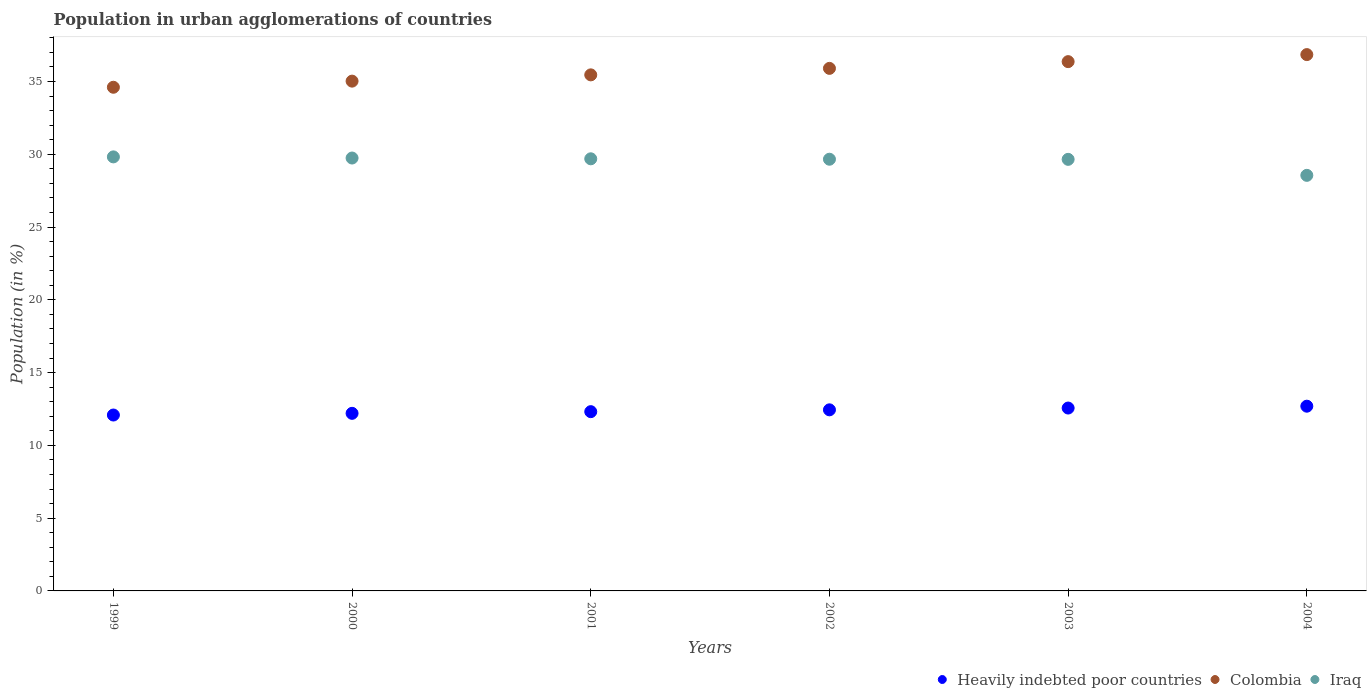What is the percentage of population in urban agglomerations in Heavily indebted poor countries in 2001?
Provide a succinct answer. 12.32. Across all years, what is the maximum percentage of population in urban agglomerations in Colombia?
Your answer should be compact. 36.85. Across all years, what is the minimum percentage of population in urban agglomerations in Colombia?
Your response must be concise. 34.61. In which year was the percentage of population in urban agglomerations in Colombia minimum?
Make the answer very short. 1999. What is the total percentage of population in urban agglomerations in Heavily indebted poor countries in the graph?
Offer a very short reply. 74.31. What is the difference between the percentage of population in urban agglomerations in Iraq in 1999 and that in 2001?
Your response must be concise. 0.13. What is the difference between the percentage of population in urban agglomerations in Iraq in 1999 and the percentage of population in urban agglomerations in Colombia in 2001?
Keep it short and to the point. -5.64. What is the average percentage of population in urban agglomerations in Heavily indebted poor countries per year?
Give a very brief answer. 12.38. In the year 2001, what is the difference between the percentage of population in urban agglomerations in Iraq and percentage of population in urban agglomerations in Colombia?
Provide a succinct answer. -5.77. In how many years, is the percentage of population in urban agglomerations in Colombia greater than 30 %?
Keep it short and to the point. 6. What is the ratio of the percentage of population in urban agglomerations in Heavily indebted poor countries in 2000 to that in 2001?
Your answer should be compact. 0.99. What is the difference between the highest and the second highest percentage of population in urban agglomerations in Iraq?
Give a very brief answer. 0.08. What is the difference between the highest and the lowest percentage of population in urban agglomerations in Iraq?
Provide a succinct answer. 1.27. In how many years, is the percentage of population in urban agglomerations in Iraq greater than the average percentage of population in urban agglomerations in Iraq taken over all years?
Make the answer very short. 5. Is it the case that in every year, the sum of the percentage of population in urban agglomerations in Heavily indebted poor countries and percentage of population in urban agglomerations in Colombia  is greater than the percentage of population in urban agglomerations in Iraq?
Your answer should be compact. Yes. Is the percentage of population in urban agglomerations in Iraq strictly greater than the percentage of population in urban agglomerations in Colombia over the years?
Offer a very short reply. No. Is the percentage of population in urban agglomerations in Colombia strictly less than the percentage of population in urban agglomerations in Iraq over the years?
Keep it short and to the point. No. Are the values on the major ticks of Y-axis written in scientific E-notation?
Ensure brevity in your answer.  No. Does the graph contain any zero values?
Your answer should be compact. No. Does the graph contain grids?
Your answer should be very brief. No. How many legend labels are there?
Your response must be concise. 3. How are the legend labels stacked?
Your answer should be compact. Horizontal. What is the title of the graph?
Your answer should be very brief. Population in urban agglomerations of countries. Does "Tonga" appear as one of the legend labels in the graph?
Your answer should be very brief. No. What is the label or title of the Y-axis?
Provide a short and direct response. Population (in %). What is the Population (in %) in Heavily indebted poor countries in 1999?
Keep it short and to the point. 12.09. What is the Population (in %) in Colombia in 1999?
Make the answer very short. 34.61. What is the Population (in %) in Iraq in 1999?
Your response must be concise. 29.82. What is the Population (in %) of Heavily indebted poor countries in 2000?
Your answer should be compact. 12.2. What is the Population (in %) of Colombia in 2000?
Your response must be concise. 35.03. What is the Population (in %) in Iraq in 2000?
Your answer should be very brief. 29.74. What is the Population (in %) in Heavily indebted poor countries in 2001?
Your response must be concise. 12.32. What is the Population (in %) in Colombia in 2001?
Your answer should be very brief. 35.46. What is the Population (in %) of Iraq in 2001?
Offer a very short reply. 29.69. What is the Population (in %) in Heavily indebted poor countries in 2002?
Your response must be concise. 12.44. What is the Population (in %) of Colombia in 2002?
Offer a terse response. 35.91. What is the Population (in %) of Iraq in 2002?
Ensure brevity in your answer.  29.66. What is the Population (in %) of Heavily indebted poor countries in 2003?
Keep it short and to the point. 12.57. What is the Population (in %) of Colombia in 2003?
Offer a very short reply. 36.37. What is the Population (in %) of Iraq in 2003?
Offer a very short reply. 29.65. What is the Population (in %) of Heavily indebted poor countries in 2004?
Ensure brevity in your answer.  12.69. What is the Population (in %) of Colombia in 2004?
Give a very brief answer. 36.85. What is the Population (in %) in Iraq in 2004?
Ensure brevity in your answer.  28.55. Across all years, what is the maximum Population (in %) in Heavily indebted poor countries?
Provide a short and direct response. 12.69. Across all years, what is the maximum Population (in %) of Colombia?
Keep it short and to the point. 36.85. Across all years, what is the maximum Population (in %) of Iraq?
Offer a very short reply. 29.82. Across all years, what is the minimum Population (in %) of Heavily indebted poor countries?
Offer a very short reply. 12.09. Across all years, what is the minimum Population (in %) in Colombia?
Ensure brevity in your answer.  34.61. Across all years, what is the minimum Population (in %) in Iraq?
Provide a short and direct response. 28.55. What is the total Population (in %) of Heavily indebted poor countries in the graph?
Your response must be concise. 74.31. What is the total Population (in %) in Colombia in the graph?
Offer a terse response. 214.22. What is the total Population (in %) in Iraq in the graph?
Offer a terse response. 177.13. What is the difference between the Population (in %) of Heavily indebted poor countries in 1999 and that in 2000?
Give a very brief answer. -0.12. What is the difference between the Population (in %) of Colombia in 1999 and that in 2000?
Offer a very short reply. -0.42. What is the difference between the Population (in %) of Iraq in 1999 and that in 2000?
Your response must be concise. 0.08. What is the difference between the Population (in %) of Heavily indebted poor countries in 1999 and that in 2001?
Your response must be concise. -0.23. What is the difference between the Population (in %) of Colombia in 1999 and that in 2001?
Make the answer very short. -0.85. What is the difference between the Population (in %) in Iraq in 1999 and that in 2001?
Keep it short and to the point. 0.13. What is the difference between the Population (in %) in Heavily indebted poor countries in 1999 and that in 2002?
Provide a short and direct response. -0.36. What is the difference between the Population (in %) in Colombia in 1999 and that in 2002?
Keep it short and to the point. -1.3. What is the difference between the Population (in %) of Iraq in 1999 and that in 2002?
Your answer should be very brief. 0.16. What is the difference between the Population (in %) of Heavily indebted poor countries in 1999 and that in 2003?
Your response must be concise. -0.48. What is the difference between the Population (in %) in Colombia in 1999 and that in 2003?
Your response must be concise. -1.76. What is the difference between the Population (in %) of Iraq in 1999 and that in 2003?
Give a very brief answer. 0.17. What is the difference between the Population (in %) of Heavily indebted poor countries in 1999 and that in 2004?
Provide a succinct answer. -0.61. What is the difference between the Population (in %) of Colombia in 1999 and that in 2004?
Offer a very short reply. -2.24. What is the difference between the Population (in %) in Iraq in 1999 and that in 2004?
Keep it short and to the point. 1.27. What is the difference between the Population (in %) of Heavily indebted poor countries in 2000 and that in 2001?
Make the answer very short. -0.12. What is the difference between the Population (in %) of Colombia in 2000 and that in 2001?
Provide a short and direct response. -0.43. What is the difference between the Population (in %) in Iraq in 2000 and that in 2001?
Provide a succinct answer. 0.05. What is the difference between the Population (in %) in Heavily indebted poor countries in 2000 and that in 2002?
Offer a terse response. -0.24. What is the difference between the Population (in %) in Colombia in 2000 and that in 2002?
Your answer should be compact. -0.88. What is the difference between the Population (in %) of Iraq in 2000 and that in 2002?
Your answer should be very brief. 0.08. What is the difference between the Population (in %) of Heavily indebted poor countries in 2000 and that in 2003?
Provide a succinct answer. -0.36. What is the difference between the Population (in %) in Colombia in 2000 and that in 2003?
Keep it short and to the point. -1.34. What is the difference between the Population (in %) in Iraq in 2000 and that in 2003?
Provide a succinct answer. 0.09. What is the difference between the Population (in %) of Heavily indebted poor countries in 2000 and that in 2004?
Give a very brief answer. -0.49. What is the difference between the Population (in %) in Colombia in 2000 and that in 2004?
Your answer should be compact. -1.82. What is the difference between the Population (in %) of Iraq in 2000 and that in 2004?
Your answer should be compact. 1.19. What is the difference between the Population (in %) in Heavily indebted poor countries in 2001 and that in 2002?
Your answer should be very brief. -0.13. What is the difference between the Population (in %) in Colombia in 2001 and that in 2002?
Make the answer very short. -0.45. What is the difference between the Population (in %) of Iraq in 2001 and that in 2002?
Ensure brevity in your answer.  0.03. What is the difference between the Population (in %) in Heavily indebted poor countries in 2001 and that in 2003?
Ensure brevity in your answer.  -0.25. What is the difference between the Population (in %) of Colombia in 2001 and that in 2003?
Make the answer very short. -0.91. What is the difference between the Population (in %) in Iraq in 2001 and that in 2003?
Your answer should be compact. 0.04. What is the difference between the Population (in %) of Heavily indebted poor countries in 2001 and that in 2004?
Keep it short and to the point. -0.38. What is the difference between the Population (in %) of Colombia in 2001 and that in 2004?
Offer a terse response. -1.39. What is the difference between the Population (in %) in Iraq in 2001 and that in 2004?
Keep it short and to the point. 1.14. What is the difference between the Population (in %) in Heavily indebted poor countries in 2002 and that in 2003?
Keep it short and to the point. -0.12. What is the difference between the Population (in %) of Colombia in 2002 and that in 2003?
Your answer should be compact. -0.46. What is the difference between the Population (in %) of Iraq in 2002 and that in 2003?
Keep it short and to the point. 0.01. What is the difference between the Population (in %) of Heavily indebted poor countries in 2002 and that in 2004?
Give a very brief answer. -0.25. What is the difference between the Population (in %) in Colombia in 2002 and that in 2004?
Offer a terse response. -0.95. What is the difference between the Population (in %) in Iraq in 2002 and that in 2004?
Your answer should be very brief. 1.11. What is the difference between the Population (in %) of Heavily indebted poor countries in 2003 and that in 2004?
Provide a succinct answer. -0.13. What is the difference between the Population (in %) in Colombia in 2003 and that in 2004?
Give a very brief answer. -0.48. What is the difference between the Population (in %) in Iraq in 2003 and that in 2004?
Your answer should be compact. 1.1. What is the difference between the Population (in %) in Heavily indebted poor countries in 1999 and the Population (in %) in Colombia in 2000?
Your answer should be very brief. -22.94. What is the difference between the Population (in %) of Heavily indebted poor countries in 1999 and the Population (in %) of Iraq in 2000?
Offer a terse response. -17.66. What is the difference between the Population (in %) of Colombia in 1999 and the Population (in %) of Iraq in 2000?
Provide a short and direct response. 4.86. What is the difference between the Population (in %) of Heavily indebted poor countries in 1999 and the Population (in %) of Colombia in 2001?
Give a very brief answer. -23.37. What is the difference between the Population (in %) of Heavily indebted poor countries in 1999 and the Population (in %) of Iraq in 2001?
Make the answer very short. -17.61. What is the difference between the Population (in %) of Colombia in 1999 and the Population (in %) of Iraq in 2001?
Offer a terse response. 4.92. What is the difference between the Population (in %) in Heavily indebted poor countries in 1999 and the Population (in %) in Colombia in 2002?
Ensure brevity in your answer.  -23.82. What is the difference between the Population (in %) in Heavily indebted poor countries in 1999 and the Population (in %) in Iraq in 2002?
Keep it short and to the point. -17.58. What is the difference between the Population (in %) in Colombia in 1999 and the Population (in %) in Iraq in 2002?
Your answer should be very brief. 4.95. What is the difference between the Population (in %) in Heavily indebted poor countries in 1999 and the Population (in %) in Colombia in 2003?
Your response must be concise. -24.28. What is the difference between the Population (in %) of Heavily indebted poor countries in 1999 and the Population (in %) of Iraq in 2003?
Provide a succinct answer. -17.57. What is the difference between the Population (in %) in Colombia in 1999 and the Population (in %) in Iraq in 2003?
Your answer should be compact. 4.95. What is the difference between the Population (in %) of Heavily indebted poor countries in 1999 and the Population (in %) of Colombia in 2004?
Keep it short and to the point. -24.77. What is the difference between the Population (in %) of Heavily indebted poor countries in 1999 and the Population (in %) of Iraq in 2004?
Your answer should be compact. -16.47. What is the difference between the Population (in %) in Colombia in 1999 and the Population (in %) in Iraq in 2004?
Your answer should be very brief. 6.05. What is the difference between the Population (in %) of Heavily indebted poor countries in 2000 and the Population (in %) of Colombia in 2001?
Provide a short and direct response. -23.26. What is the difference between the Population (in %) of Heavily indebted poor countries in 2000 and the Population (in %) of Iraq in 2001?
Provide a short and direct response. -17.49. What is the difference between the Population (in %) in Colombia in 2000 and the Population (in %) in Iraq in 2001?
Your response must be concise. 5.34. What is the difference between the Population (in %) in Heavily indebted poor countries in 2000 and the Population (in %) in Colombia in 2002?
Provide a succinct answer. -23.7. What is the difference between the Population (in %) of Heavily indebted poor countries in 2000 and the Population (in %) of Iraq in 2002?
Offer a very short reply. -17.46. What is the difference between the Population (in %) of Colombia in 2000 and the Population (in %) of Iraq in 2002?
Your answer should be very brief. 5.37. What is the difference between the Population (in %) in Heavily indebted poor countries in 2000 and the Population (in %) in Colombia in 2003?
Provide a short and direct response. -24.17. What is the difference between the Population (in %) in Heavily indebted poor countries in 2000 and the Population (in %) in Iraq in 2003?
Keep it short and to the point. -17.45. What is the difference between the Population (in %) in Colombia in 2000 and the Population (in %) in Iraq in 2003?
Your answer should be very brief. 5.37. What is the difference between the Population (in %) in Heavily indebted poor countries in 2000 and the Population (in %) in Colombia in 2004?
Provide a short and direct response. -24.65. What is the difference between the Population (in %) of Heavily indebted poor countries in 2000 and the Population (in %) of Iraq in 2004?
Make the answer very short. -16.35. What is the difference between the Population (in %) in Colombia in 2000 and the Population (in %) in Iraq in 2004?
Your answer should be compact. 6.47. What is the difference between the Population (in %) of Heavily indebted poor countries in 2001 and the Population (in %) of Colombia in 2002?
Give a very brief answer. -23.59. What is the difference between the Population (in %) in Heavily indebted poor countries in 2001 and the Population (in %) in Iraq in 2002?
Provide a short and direct response. -17.35. What is the difference between the Population (in %) in Colombia in 2001 and the Population (in %) in Iraq in 2002?
Offer a very short reply. 5.8. What is the difference between the Population (in %) in Heavily indebted poor countries in 2001 and the Population (in %) in Colombia in 2003?
Provide a short and direct response. -24.05. What is the difference between the Population (in %) in Heavily indebted poor countries in 2001 and the Population (in %) in Iraq in 2003?
Your response must be concise. -17.34. What is the difference between the Population (in %) in Colombia in 2001 and the Population (in %) in Iraq in 2003?
Provide a succinct answer. 5.81. What is the difference between the Population (in %) in Heavily indebted poor countries in 2001 and the Population (in %) in Colombia in 2004?
Provide a succinct answer. -24.53. What is the difference between the Population (in %) of Heavily indebted poor countries in 2001 and the Population (in %) of Iraq in 2004?
Make the answer very short. -16.24. What is the difference between the Population (in %) of Colombia in 2001 and the Population (in %) of Iraq in 2004?
Keep it short and to the point. 6.9. What is the difference between the Population (in %) in Heavily indebted poor countries in 2002 and the Population (in %) in Colombia in 2003?
Offer a terse response. -23.93. What is the difference between the Population (in %) of Heavily indebted poor countries in 2002 and the Population (in %) of Iraq in 2003?
Ensure brevity in your answer.  -17.21. What is the difference between the Population (in %) in Colombia in 2002 and the Population (in %) in Iraq in 2003?
Offer a very short reply. 6.25. What is the difference between the Population (in %) in Heavily indebted poor countries in 2002 and the Population (in %) in Colombia in 2004?
Give a very brief answer. -24.41. What is the difference between the Population (in %) in Heavily indebted poor countries in 2002 and the Population (in %) in Iraq in 2004?
Your answer should be very brief. -16.11. What is the difference between the Population (in %) in Colombia in 2002 and the Population (in %) in Iraq in 2004?
Keep it short and to the point. 7.35. What is the difference between the Population (in %) in Heavily indebted poor countries in 2003 and the Population (in %) in Colombia in 2004?
Your answer should be compact. -24.29. What is the difference between the Population (in %) of Heavily indebted poor countries in 2003 and the Population (in %) of Iraq in 2004?
Your response must be concise. -15.99. What is the difference between the Population (in %) of Colombia in 2003 and the Population (in %) of Iraq in 2004?
Your response must be concise. 7.81. What is the average Population (in %) of Heavily indebted poor countries per year?
Make the answer very short. 12.38. What is the average Population (in %) in Colombia per year?
Give a very brief answer. 35.7. What is the average Population (in %) in Iraq per year?
Offer a very short reply. 29.52. In the year 1999, what is the difference between the Population (in %) in Heavily indebted poor countries and Population (in %) in Colombia?
Your answer should be very brief. -22.52. In the year 1999, what is the difference between the Population (in %) in Heavily indebted poor countries and Population (in %) in Iraq?
Provide a short and direct response. -17.74. In the year 1999, what is the difference between the Population (in %) in Colombia and Population (in %) in Iraq?
Make the answer very short. 4.78. In the year 2000, what is the difference between the Population (in %) in Heavily indebted poor countries and Population (in %) in Colombia?
Make the answer very short. -22.83. In the year 2000, what is the difference between the Population (in %) of Heavily indebted poor countries and Population (in %) of Iraq?
Make the answer very short. -17.54. In the year 2000, what is the difference between the Population (in %) in Colombia and Population (in %) in Iraq?
Make the answer very short. 5.28. In the year 2001, what is the difference between the Population (in %) in Heavily indebted poor countries and Population (in %) in Colombia?
Make the answer very short. -23.14. In the year 2001, what is the difference between the Population (in %) in Heavily indebted poor countries and Population (in %) in Iraq?
Your answer should be very brief. -17.37. In the year 2001, what is the difference between the Population (in %) of Colombia and Population (in %) of Iraq?
Your answer should be compact. 5.77. In the year 2002, what is the difference between the Population (in %) of Heavily indebted poor countries and Population (in %) of Colombia?
Provide a succinct answer. -23.46. In the year 2002, what is the difference between the Population (in %) of Heavily indebted poor countries and Population (in %) of Iraq?
Your response must be concise. -17.22. In the year 2002, what is the difference between the Population (in %) in Colombia and Population (in %) in Iraq?
Your response must be concise. 6.24. In the year 2003, what is the difference between the Population (in %) in Heavily indebted poor countries and Population (in %) in Colombia?
Provide a short and direct response. -23.8. In the year 2003, what is the difference between the Population (in %) in Heavily indebted poor countries and Population (in %) in Iraq?
Ensure brevity in your answer.  -17.09. In the year 2003, what is the difference between the Population (in %) in Colombia and Population (in %) in Iraq?
Offer a terse response. 6.71. In the year 2004, what is the difference between the Population (in %) of Heavily indebted poor countries and Population (in %) of Colombia?
Make the answer very short. -24.16. In the year 2004, what is the difference between the Population (in %) in Heavily indebted poor countries and Population (in %) in Iraq?
Make the answer very short. -15.86. In the year 2004, what is the difference between the Population (in %) in Colombia and Population (in %) in Iraq?
Provide a succinct answer. 8.3. What is the ratio of the Population (in %) of Colombia in 1999 to that in 2000?
Make the answer very short. 0.99. What is the ratio of the Population (in %) of Iraq in 1999 to that in 2000?
Provide a succinct answer. 1. What is the ratio of the Population (in %) in Heavily indebted poor countries in 1999 to that in 2001?
Your response must be concise. 0.98. What is the ratio of the Population (in %) in Iraq in 1999 to that in 2001?
Provide a short and direct response. 1. What is the ratio of the Population (in %) of Heavily indebted poor countries in 1999 to that in 2002?
Provide a succinct answer. 0.97. What is the ratio of the Population (in %) of Colombia in 1999 to that in 2002?
Provide a succinct answer. 0.96. What is the ratio of the Population (in %) in Iraq in 1999 to that in 2002?
Your answer should be very brief. 1.01. What is the ratio of the Population (in %) in Heavily indebted poor countries in 1999 to that in 2003?
Provide a succinct answer. 0.96. What is the ratio of the Population (in %) of Colombia in 1999 to that in 2003?
Offer a terse response. 0.95. What is the ratio of the Population (in %) in Iraq in 1999 to that in 2003?
Offer a very short reply. 1.01. What is the ratio of the Population (in %) of Heavily indebted poor countries in 1999 to that in 2004?
Your response must be concise. 0.95. What is the ratio of the Population (in %) of Colombia in 1999 to that in 2004?
Keep it short and to the point. 0.94. What is the ratio of the Population (in %) of Iraq in 1999 to that in 2004?
Your response must be concise. 1.04. What is the ratio of the Population (in %) in Heavily indebted poor countries in 2000 to that in 2001?
Offer a very short reply. 0.99. What is the ratio of the Population (in %) of Colombia in 2000 to that in 2001?
Provide a short and direct response. 0.99. What is the ratio of the Population (in %) in Iraq in 2000 to that in 2001?
Provide a succinct answer. 1. What is the ratio of the Population (in %) in Heavily indebted poor countries in 2000 to that in 2002?
Keep it short and to the point. 0.98. What is the ratio of the Population (in %) in Colombia in 2000 to that in 2002?
Keep it short and to the point. 0.98. What is the ratio of the Population (in %) in Iraq in 2000 to that in 2002?
Your answer should be very brief. 1. What is the ratio of the Population (in %) of Heavily indebted poor countries in 2000 to that in 2003?
Keep it short and to the point. 0.97. What is the ratio of the Population (in %) in Colombia in 2000 to that in 2003?
Make the answer very short. 0.96. What is the ratio of the Population (in %) of Iraq in 2000 to that in 2003?
Provide a short and direct response. 1. What is the ratio of the Population (in %) in Heavily indebted poor countries in 2000 to that in 2004?
Make the answer very short. 0.96. What is the ratio of the Population (in %) of Colombia in 2000 to that in 2004?
Your response must be concise. 0.95. What is the ratio of the Population (in %) of Iraq in 2000 to that in 2004?
Offer a terse response. 1.04. What is the ratio of the Population (in %) in Colombia in 2001 to that in 2002?
Give a very brief answer. 0.99. What is the ratio of the Population (in %) in Heavily indebted poor countries in 2001 to that in 2003?
Give a very brief answer. 0.98. What is the ratio of the Population (in %) in Iraq in 2001 to that in 2003?
Your answer should be compact. 1. What is the ratio of the Population (in %) in Heavily indebted poor countries in 2001 to that in 2004?
Your answer should be compact. 0.97. What is the ratio of the Population (in %) in Colombia in 2001 to that in 2004?
Your response must be concise. 0.96. What is the ratio of the Population (in %) in Iraq in 2001 to that in 2004?
Your answer should be very brief. 1.04. What is the ratio of the Population (in %) in Heavily indebted poor countries in 2002 to that in 2003?
Provide a succinct answer. 0.99. What is the ratio of the Population (in %) of Colombia in 2002 to that in 2003?
Provide a short and direct response. 0.99. What is the ratio of the Population (in %) in Heavily indebted poor countries in 2002 to that in 2004?
Your answer should be compact. 0.98. What is the ratio of the Population (in %) of Colombia in 2002 to that in 2004?
Your answer should be very brief. 0.97. What is the ratio of the Population (in %) of Iraq in 2002 to that in 2004?
Your answer should be very brief. 1.04. What is the ratio of the Population (in %) in Colombia in 2003 to that in 2004?
Your answer should be very brief. 0.99. What is the ratio of the Population (in %) in Iraq in 2003 to that in 2004?
Give a very brief answer. 1.04. What is the difference between the highest and the second highest Population (in %) in Heavily indebted poor countries?
Your answer should be very brief. 0.13. What is the difference between the highest and the second highest Population (in %) in Colombia?
Your response must be concise. 0.48. What is the difference between the highest and the second highest Population (in %) in Iraq?
Offer a very short reply. 0.08. What is the difference between the highest and the lowest Population (in %) in Heavily indebted poor countries?
Provide a short and direct response. 0.61. What is the difference between the highest and the lowest Population (in %) of Colombia?
Your answer should be compact. 2.24. What is the difference between the highest and the lowest Population (in %) of Iraq?
Your answer should be very brief. 1.27. 